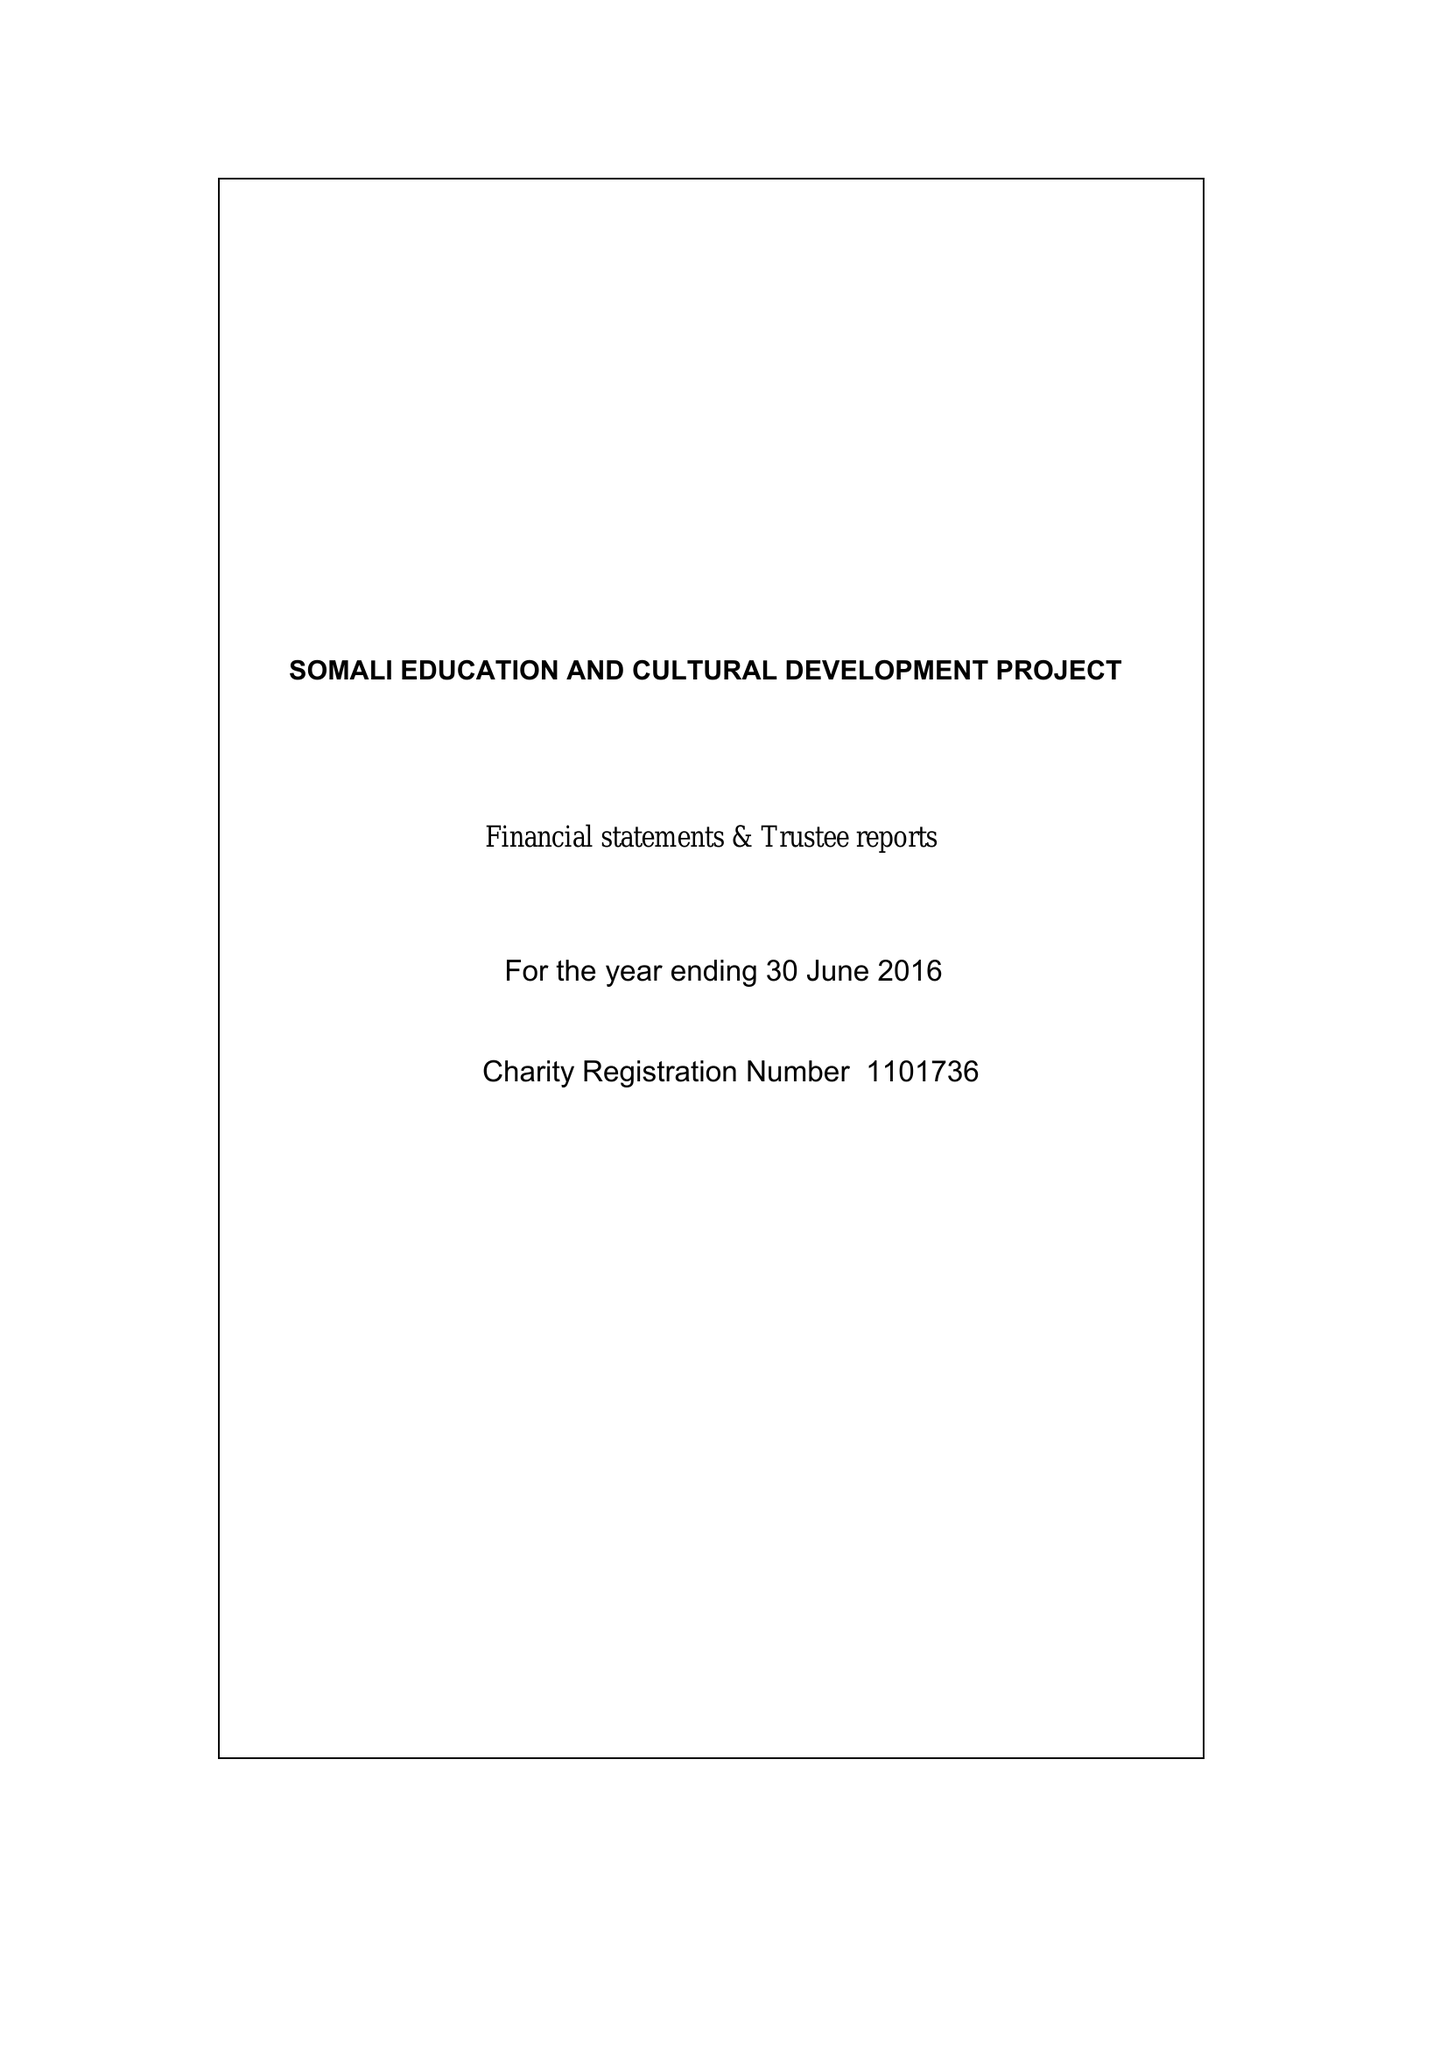What is the value for the income_annually_in_british_pounds?
Answer the question using a single word or phrase. 35642.00 